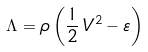<formula> <loc_0><loc_0><loc_500><loc_500>\Lambda = \rho \left ( \frac { 1 } { 2 } \, V ^ { 2 } - \varepsilon \right )</formula> 